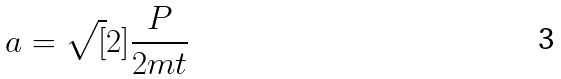Convert formula to latex. <formula><loc_0><loc_0><loc_500><loc_500>a = \sqrt { [ } 2 ] { \frac { P } { 2 m t } }</formula> 